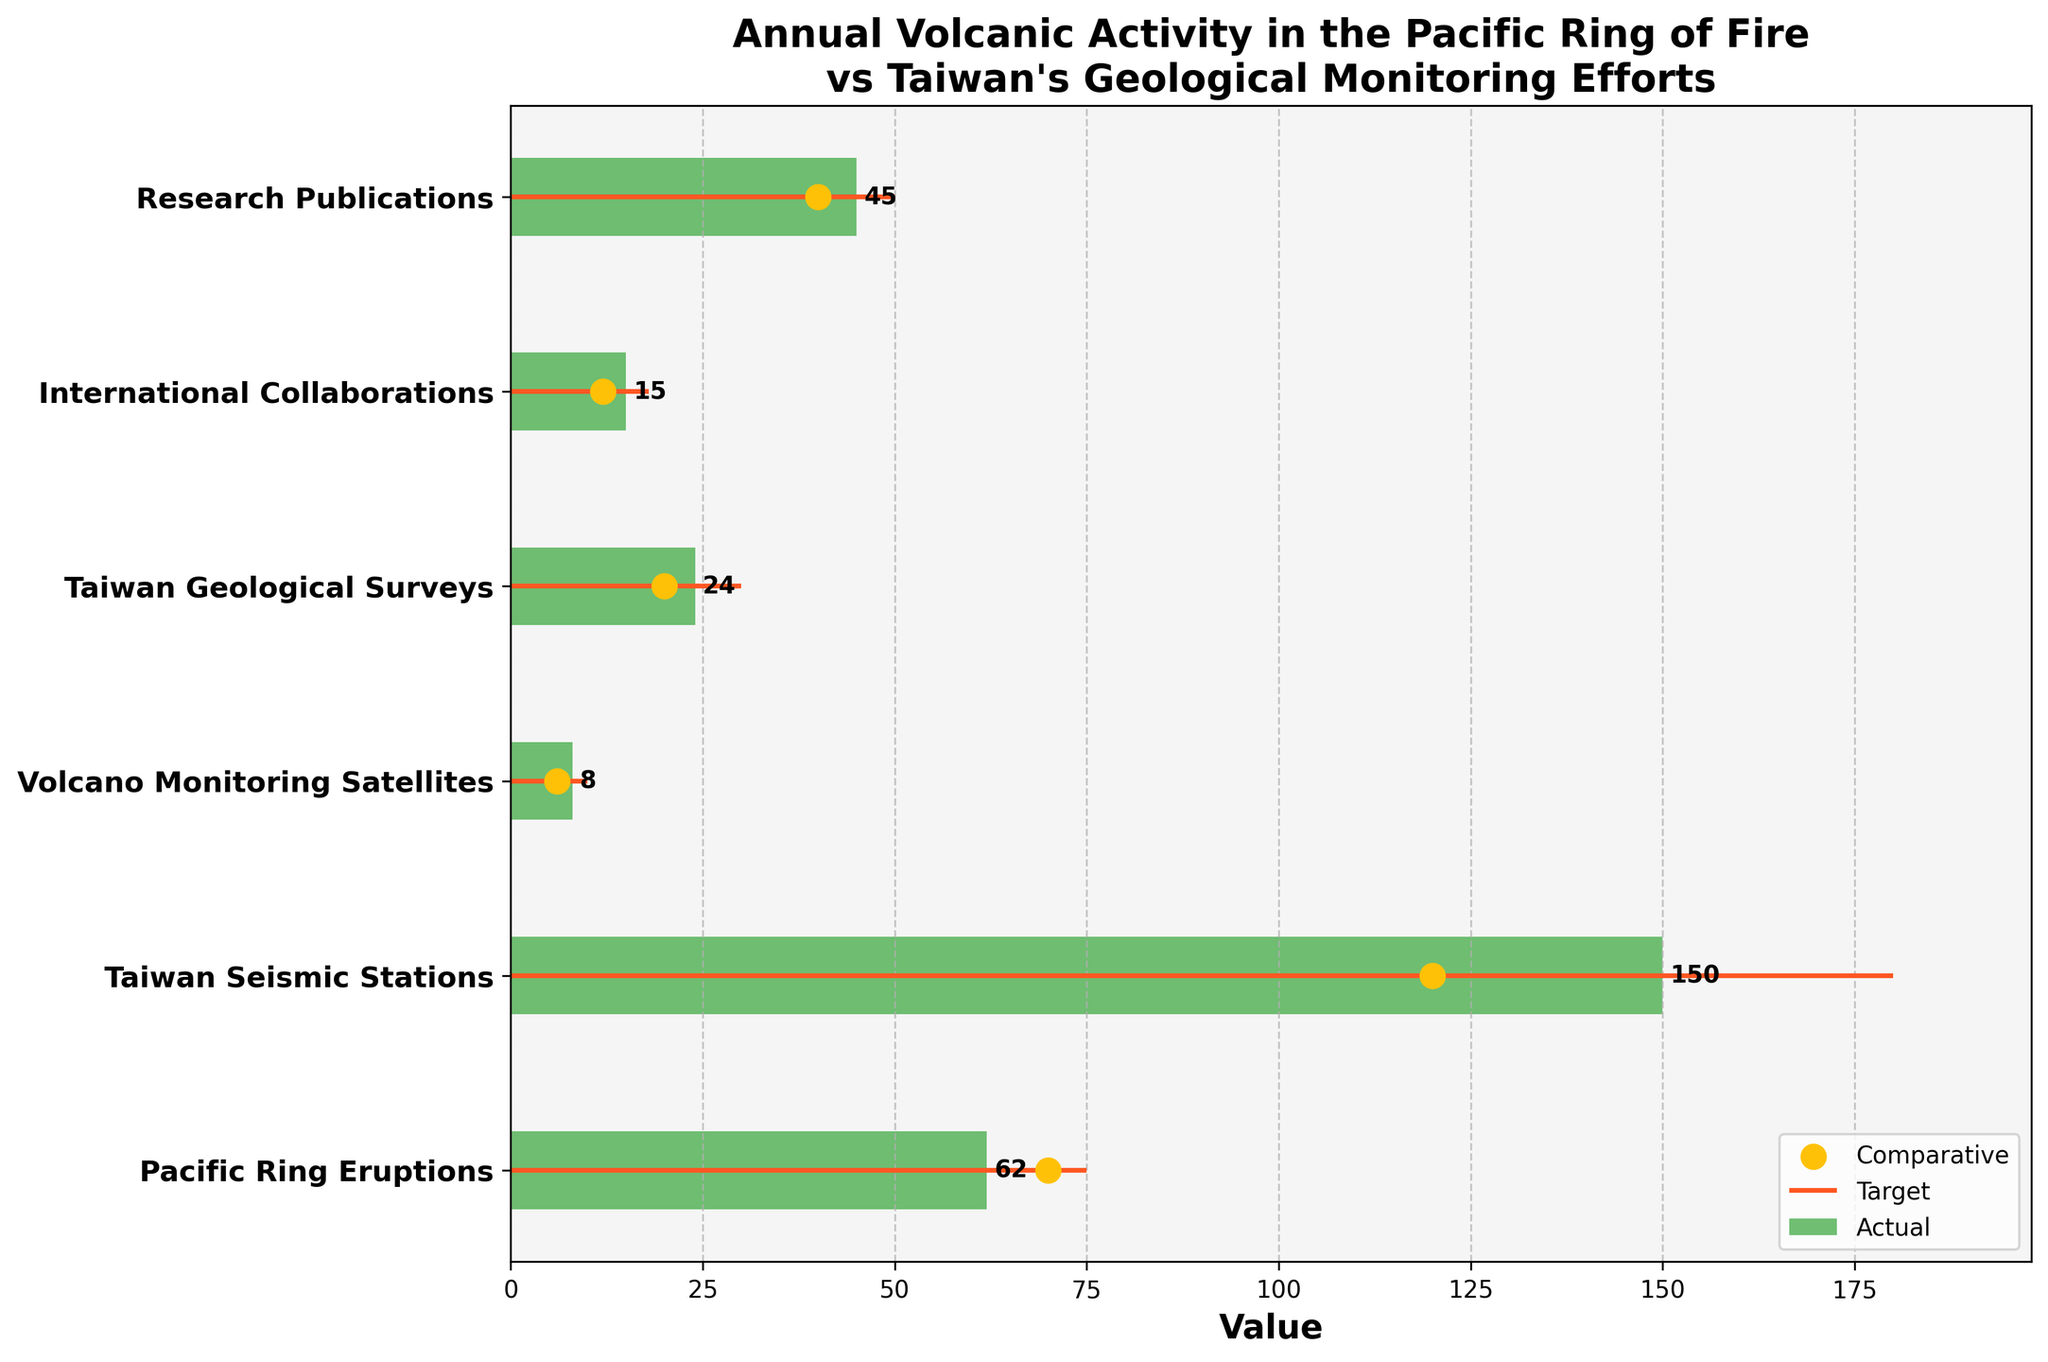what is the actual number of annual Pacific Ring eruptions shown in the figure? The bar for "Pacific Ring Eruptions" indicates the actual number is 62.
Answer: 62 How many total data categories are included in the figure? There are six different categories listed on the y-axis, each representing a different aspect of geological monitoring and volcanic activity.
Answer: 6 What is the difference between the number of Taiwan Seismic Stations and the target number for this category? The target number of Taiwan Seismic Stations is 180, while the actual number is 150. The difference is 180 - 150 = 30.
Answer: 30 Which category has the smallest actual value? The category with the smallest bar for the actual value is "Volcano Monitoring Satellites," with a value of 8.
Answer: Volcano Monitoring Satellites For the "Research Publications" category, is the actual value higher or lower than the comparative value? The actual value for "Research Publications" is 45, while the comparative value is 40, making the actual value higher.
Answer: Higher What is the sum of the actual values for "Taiwan Seismic Stations," "Volcano Monitoring Satellites," and "Taiwan Geological Surveys"? The actual values are 150 for Taiwan Seismic Stations, 8 for Volcano Monitoring Satellites, and 24 for Taiwan Geological Surveys. Adding them up gives 150 + 8 + 24 = 182.
Answer: 182 In which category does the actual value exceed both the comparative and target values? "Taiwan Seismic Stations" is the only category where the actual value (150) is higher than both the comparative (120) and target (180) values.
Answer: Taiwan Seismic Stations What is the average target value across all the categories? The target values are 75, 180, 10, 30, 18, and 50. Summing these gives 75 + 180 + 10 + 30 + 18 + 50 = 363, and dividing by the number of categories (6) gives 363 / 6 = 60.5.
Answer: 60.5 Between "International Collaborations" and "Research Publications," which category has a higher comparative value? The comparative value for "International Collaborations" is 12, whereas for "Research Publications," it is 40. "Research Publications" has a higher comparative value.
Answer: Research Publications How much higher is the actual value for "Pacific Ring Eruptions" compared to the comparative value for "Volcano Monitoring Satellites"? The actual value for "Pacific Ring Eruptions" is 62, and the comparative value for "Volcano Monitoring Satellites" is 6. The comparison yields 62 - 6 = 56.
Answer: 56 